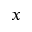<formula> <loc_0><loc_0><loc_500><loc_500>x</formula> 